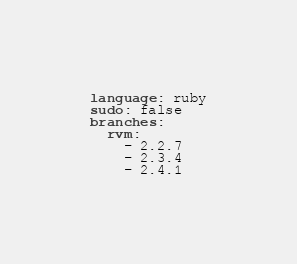<code> <loc_0><loc_0><loc_500><loc_500><_YAML_>language: ruby
sudo: false
branches:
  rvm:
    - 2.2.7
    - 2.3.4
    - 2.4.1
</code> 